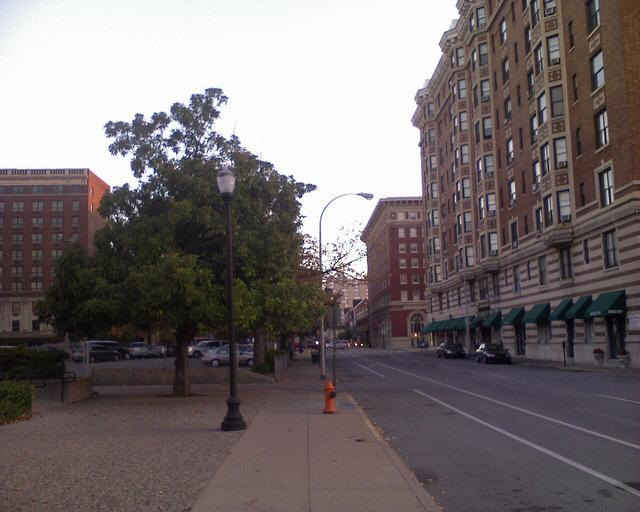During which season are the cars on this street parked? Please explain your reasoning. fall. The leaves on the tree appear to be changing from green to orange a red which happens during the autumn season. 